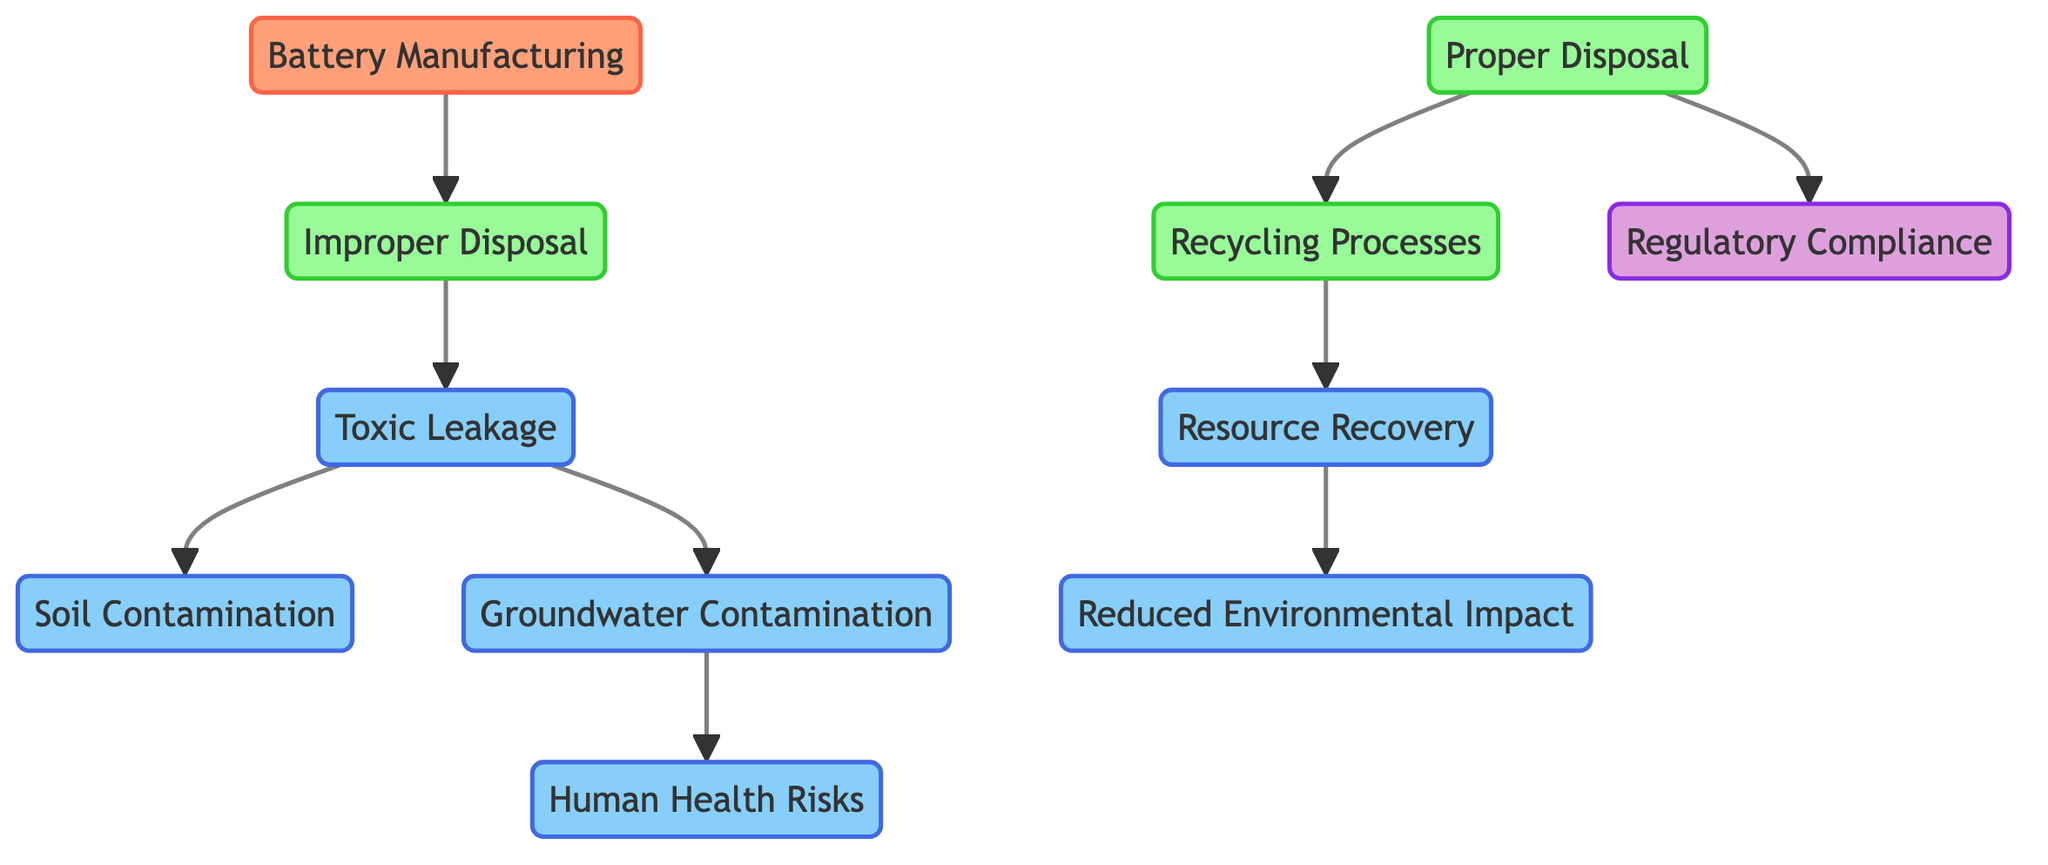What are the two main categories of battery disposal shown in the diagram? The diagram shows two main categories of battery disposal: "Improper Disposal" and "Proper Disposal." These categories are distinct nodes originating from the "Battery Manufacturing" node, illustrating different approaches to battery disposal.
Answer: Improper Disposal, Proper Disposal How many impacts of improper disposal are identified in the diagram? The diagram identifies four impacts stemming from "Improper Disposal": "Toxic Leakage," "Soil Contamination," "Groundwater Contamination," and "Human Health Risks." This is based on the connections leading from "Improper Disposal" to these impacting nodes.
Answer: 4 What is the final outcome of the "Recycling Processes"? The final outcome of the "Recycling Processes" is "Resource Recovery." The diagram shows a directed edge from "Recycling Processes" to "Resource Recovery," indicating that this process leads to the recovery of resources.
Answer: Resource Recovery What leads to "Reduced Environmental Impact"? "Reduced Environmental Impact" is reached through "Resource Recovery." The pathway from "Recycling Processes" to "Resource Recovery" ultimately leads to this positive environmental outcome, representing a beneficial consequence of proper disposal and recycling efforts.
Answer: Resource Recovery What is the connection between "Groundwater Contamination" and "Human Health Risks"? The connection is from "Groundwater Contamination" to "Human Health Risks." This indicates that groundwater contamination poses risks to human health, demonstrating a critical consequence of improper battery disposal practices.
Answer: Human Health Risks 